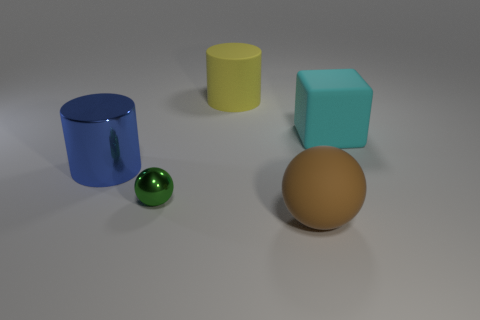Does the large block have the same color as the small object?
Your response must be concise. No. Are there any purple matte objects that have the same size as the metallic cylinder?
Provide a short and direct response. No. How big is the ball to the right of the yellow thing?
Your response must be concise. Large. Are there any big shiny cylinders that are in front of the cylinder that is behind the big cyan matte thing?
Provide a succinct answer. Yes. How many other objects are the same shape as the big cyan rubber thing?
Keep it short and to the point. 0. Does the cyan rubber object have the same shape as the green thing?
Offer a very short reply. No. What color is the large matte object that is to the right of the big yellow cylinder and on the left side of the cyan cube?
Ensure brevity in your answer.  Brown. What number of small objects are either blue shiny objects or cyan matte cubes?
Give a very brief answer. 0. Is there any other thing that has the same color as the big metallic object?
Your response must be concise. No. There is a large cylinder that is to the right of the big object to the left of the thing that is behind the large cyan matte block; what is its material?
Give a very brief answer. Rubber. 